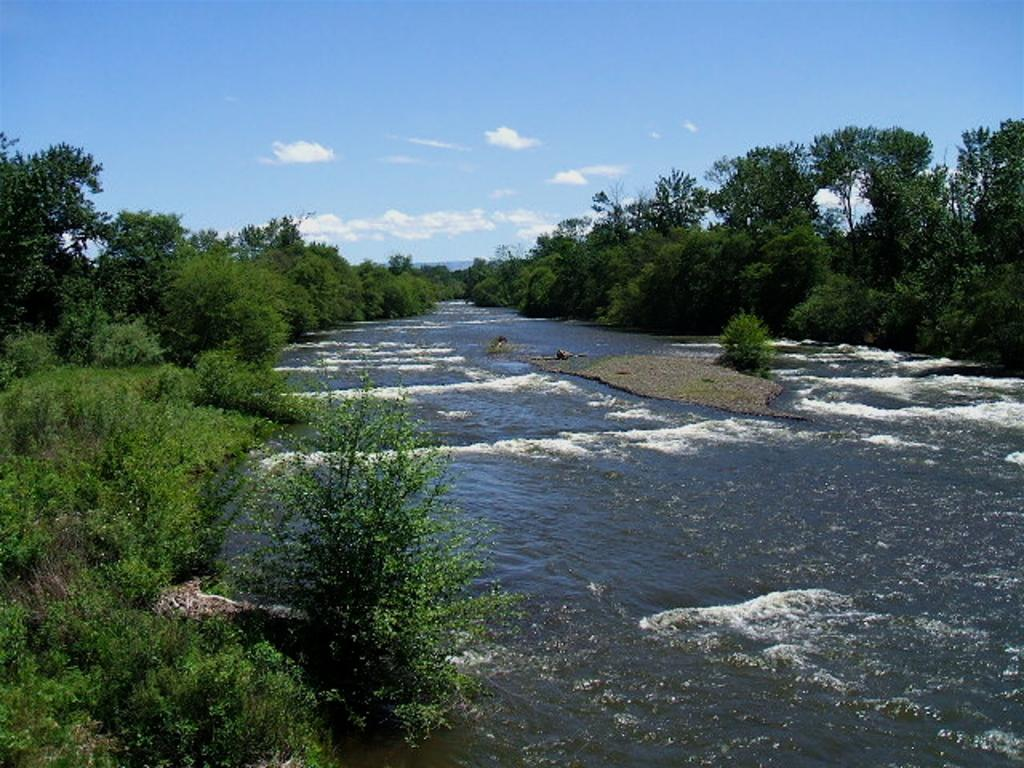What is the primary element visible in the image? There is water in the image. What surrounds the water in the image? There are plants on either side of the water. What can be seen in the background of the image? There are trees, a hill, and the sky visible in the background of the image. What is the condition of the sky in the image? Clouds are present in the sky. What type of cream can be seen in the image? There is no cream present in the image. 